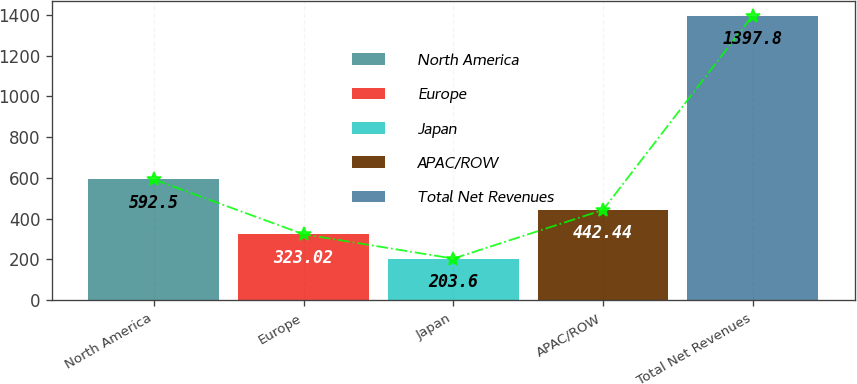Convert chart. <chart><loc_0><loc_0><loc_500><loc_500><bar_chart><fcel>North America<fcel>Europe<fcel>Japan<fcel>APAC/ROW<fcel>Total Net Revenues<nl><fcel>592.5<fcel>323.02<fcel>203.6<fcel>442.44<fcel>1397.8<nl></chart> 